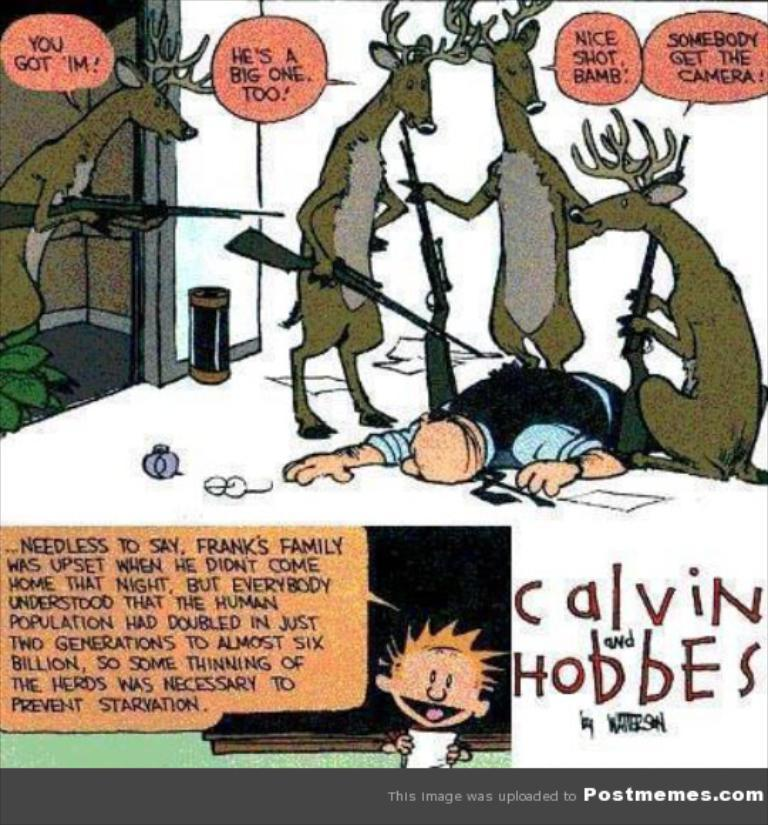What type of content is featured in the image? The image contains a cartoon. What types of characters are present in the cartoon? There are animals and persons in the cartoon. What are the animals doing in the cartoon? The animals are holding guns. Is there any text present in the image? Yes, there is text written on the image. How many forks can be seen in the image? There are no forks present in the image. Is there an owl in the image? There is no owl present in the image. 